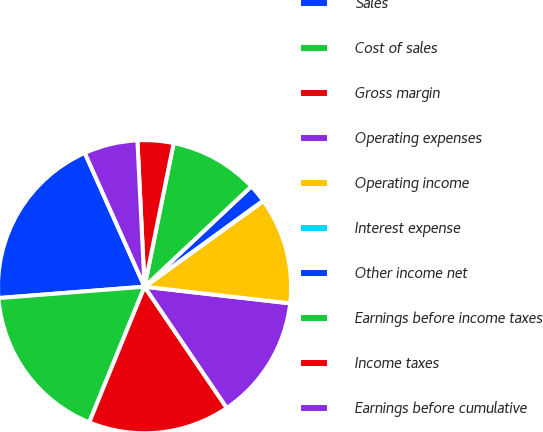Convert chart to OTSL. <chart><loc_0><loc_0><loc_500><loc_500><pie_chart><fcel>Sales<fcel>Cost of sales<fcel>Gross margin<fcel>Operating expenses<fcel>Operating income<fcel>Interest expense<fcel>Other income net<fcel>Earnings before income taxes<fcel>Income taxes<fcel>Earnings before cumulative<nl><fcel>19.55%<fcel>17.6%<fcel>15.65%<fcel>13.7%<fcel>11.75%<fcel>0.06%<fcel>2.01%<fcel>9.81%<fcel>3.96%<fcel>5.91%<nl></chart> 